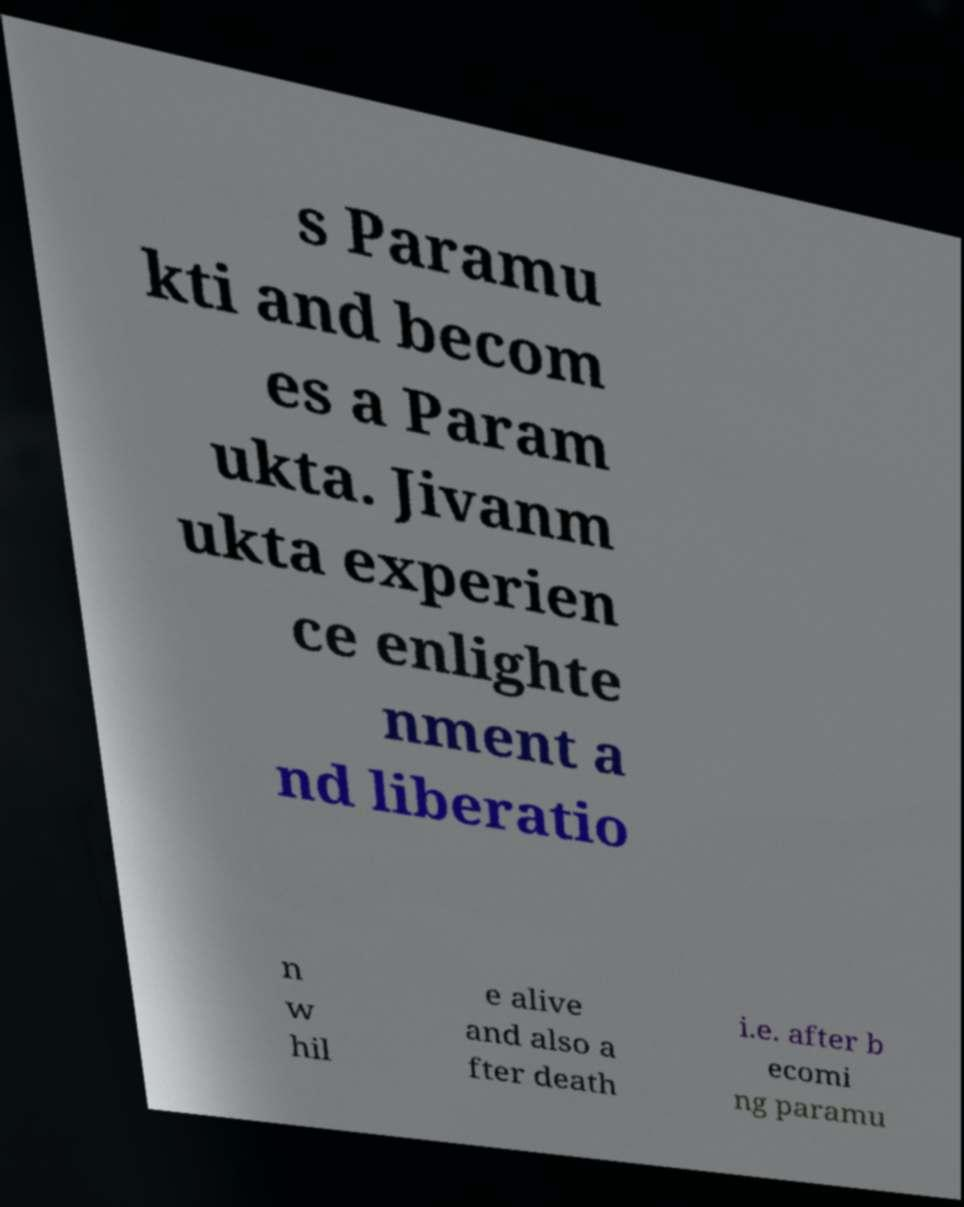Could you extract and type out the text from this image? s Paramu kti and becom es a Param ukta. Jivanm ukta experien ce enlighte nment a nd liberatio n w hil e alive and also a fter death i.e. after b ecomi ng paramu 